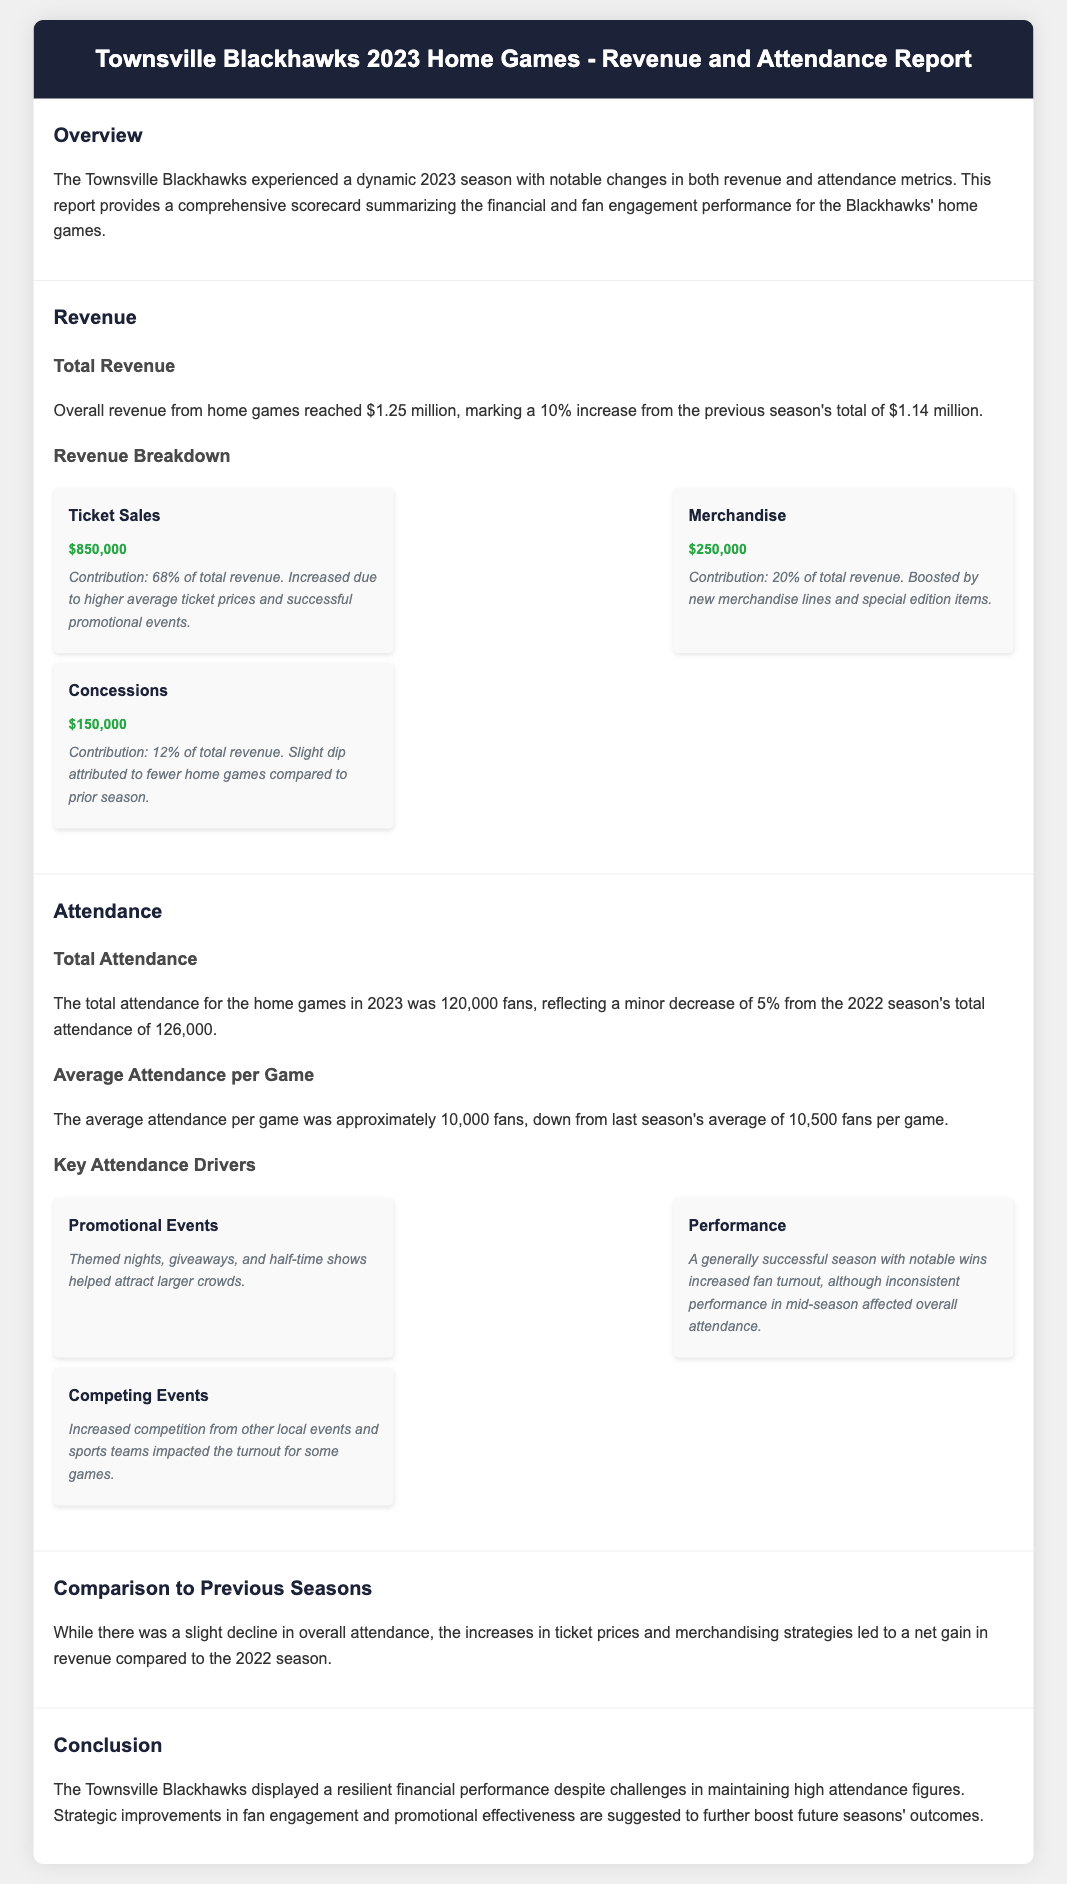what was the total revenue? The total revenue is stated in the document as $1.25 million for the 2023 season.
Answer: $1.25 million how much did ticket sales contribute to total revenue? Ticket sales contributed 68% of the total revenue as mentioned in the breakdown.
Answer: 68% what is the total attendance for the home games? The document mentions that the total attendance was 120,000 fans for the 2023 season.
Answer: 120,000 fans what was the average attendance per game in 2023? The average attendance per game is indicated as approximately 10,000 fans.
Answer: 10,000 fans what was the percentage increase in total revenue from the previous season? The report states that there was a 10% increase in total revenue compared to the previous season.
Answer: 10% which revenue source had the highest contribution? The highest contribution came from ticket sales, which is highlighted in the revenue breakdown section.
Answer: Ticket Sales what factors contributed to attendance changes? The document outlines several factors, including promotional events, performance, and competing events.
Answer: Promotional events, performance, competing events what was the revenue from merchandise sales? The document specifies that revenue from merchandise sales was $250,000.
Answer: $250,000 what is indicated as a recommendation for future performance? The conclusion suggests that strategic improvements in fan engagement and promotions are needed.
Answer: Strategic improvements in fan engagement what was the comment regarding concessions revenue? The document notes a slight dip in concessions revenue attributed to fewer home games compared to the previous season.
Answer: A slight dip attributed to fewer home games 